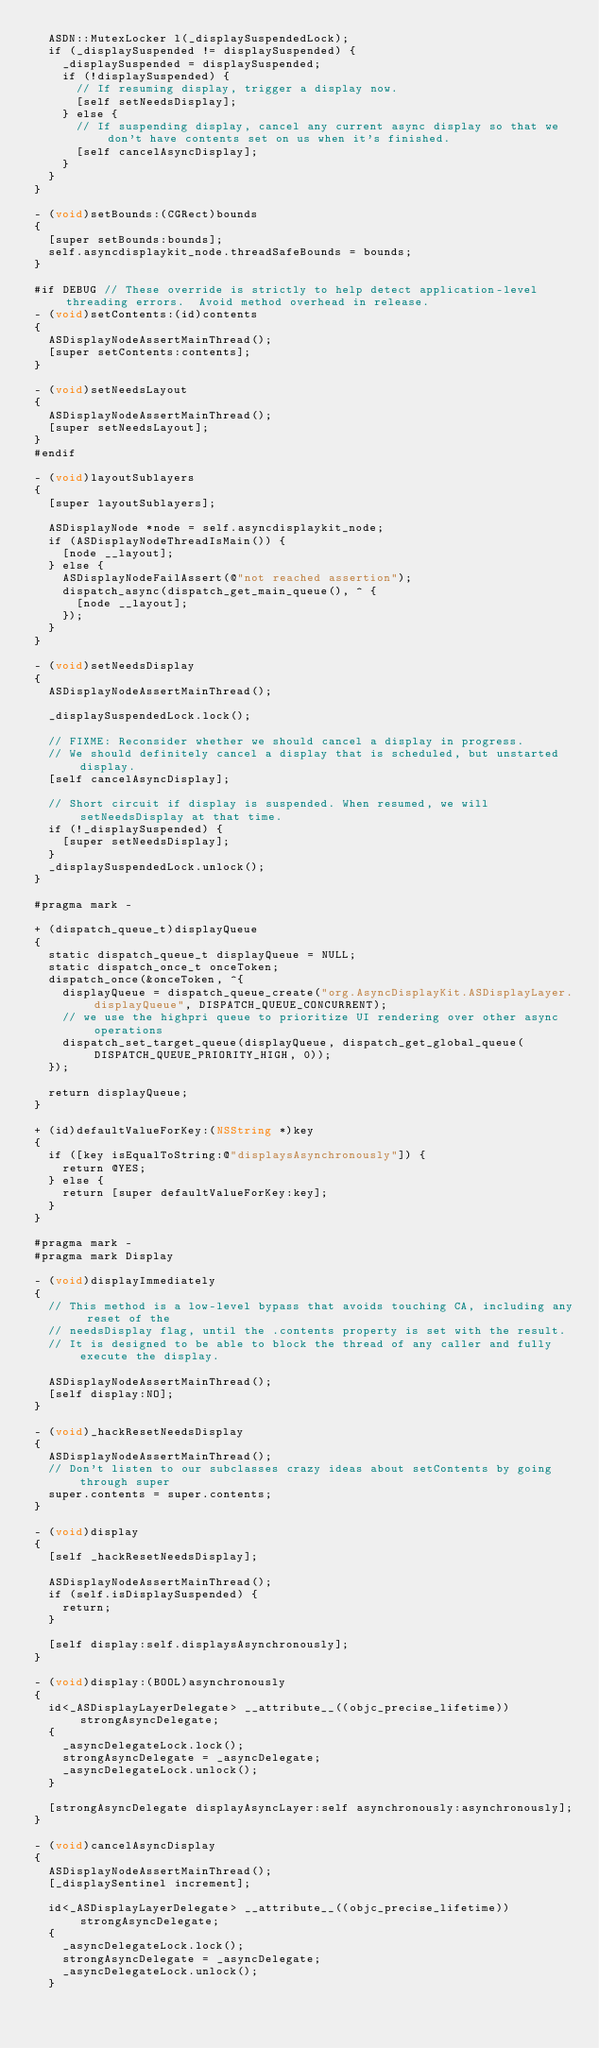Convert code to text. <code><loc_0><loc_0><loc_500><loc_500><_ObjectiveC_>  ASDN::MutexLocker l(_displaySuspendedLock);
  if (_displaySuspended != displaySuspended) {
    _displaySuspended = displaySuspended;
    if (!displaySuspended) {
      // If resuming display, trigger a display now.
      [self setNeedsDisplay];
    } else {
      // If suspending display, cancel any current async display so that we don't have contents set on us when it's finished.
      [self cancelAsyncDisplay];
    }
  }
}

- (void)setBounds:(CGRect)bounds
{
  [super setBounds:bounds];
  self.asyncdisplaykit_node.threadSafeBounds = bounds;
}

#if DEBUG // These override is strictly to help detect application-level threading errors.  Avoid method overhead in release.
- (void)setContents:(id)contents
{
  ASDisplayNodeAssertMainThread();
  [super setContents:contents];
}

- (void)setNeedsLayout
{
  ASDisplayNodeAssertMainThread();
  [super setNeedsLayout];
}
#endif

- (void)layoutSublayers
{ 
  [super layoutSublayers];

  ASDisplayNode *node = self.asyncdisplaykit_node;
  if (ASDisplayNodeThreadIsMain()) {
    [node __layout];
  } else {
    ASDisplayNodeFailAssert(@"not reached assertion");
    dispatch_async(dispatch_get_main_queue(), ^ {
      [node __layout];
    });
  }
}

- (void)setNeedsDisplay
{
  ASDisplayNodeAssertMainThread();

  _displaySuspendedLock.lock();
  
  // FIXME: Reconsider whether we should cancel a display in progress.
  // We should definitely cancel a display that is scheduled, but unstarted display.
  [self cancelAsyncDisplay];

  // Short circuit if display is suspended. When resumed, we will setNeedsDisplay at that time.
  if (!_displaySuspended) {
    [super setNeedsDisplay];
  }
  _displaySuspendedLock.unlock();
}

#pragma mark -

+ (dispatch_queue_t)displayQueue
{
  static dispatch_queue_t displayQueue = NULL;
  static dispatch_once_t onceToken;
  dispatch_once(&onceToken, ^{
    displayQueue = dispatch_queue_create("org.AsyncDisplayKit.ASDisplayLayer.displayQueue", DISPATCH_QUEUE_CONCURRENT);
    // we use the highpri queue to prioritize UI rendering over other async operations
    dispatch_set_target_queue(displayQueue, dispatch_get_global_queue(DISPATCH_QUEUE_PRIORITY_HIGH, 0));
  });

  return displayQueue;
}

+ (id)defaultValueForKey:(NSString *)key
{
  if ([key isEqualToString:@"displaysAsynchronously"]) {
    return @YES;
  } else {
    return [super defaultValueForKey:key];
  }
}

#pragma mark -
#pragma mark Display

- (void)displayImmediately
{
  // This method is a low-level bypass that avoids touching CA, including any reset of the
  // needsDisplay flag, until the .contents property is set with the result.
  // It is designed to be able to block the thread of any caller and fully execute the display.

  ASDisplayNodeAssertMainThread();
  [self display:NO];
}

- (void)_hackResetNeedsDisplay
{
  ASDisplayNodeAssertMainThread();
  // Don't listen to our subclasses crazy ideas about setContents by going through super
  super.contents = super.contents;
}

- (void)display
{
  [self _hackResetNeedsDisplay];

  ASDisplayNodeAssertMainThread();
  if (self.isDisplaySuspended) {
    return;
  }

  [self display:self.displaysAsynchronously];
}

- (void)display:(BOOL)asynchronously
{
  id<_ASDisplayLayerDelegate> __attribute__((objc_precise_lifetime)) strongAsyncDelegate;
  {
    _asyncDelegateLock.lock();
    strongAsyncDelegate = _asyncDelegate;
    _asyncDelegateLock.unlock();
  }
  
  [strongAsyncDelegate displayAsyncLayer:self asynchronously:asynchronously];
}

- (void)cancelAsyncDisplay
{
  ASDisplayNodeAssertMainThread();
  [_displaySentinel increment];

  id<_ASDisplayLayerDelegate> __attribute__((objc_precise_lifetime)) strongAsyncDelegate;
  {
    _asyncDelegateLock.lock();
    strongAsyncDelegate = _asyncDelegate;
    _asyncDelegateLock.unlock();
  }
</code> 